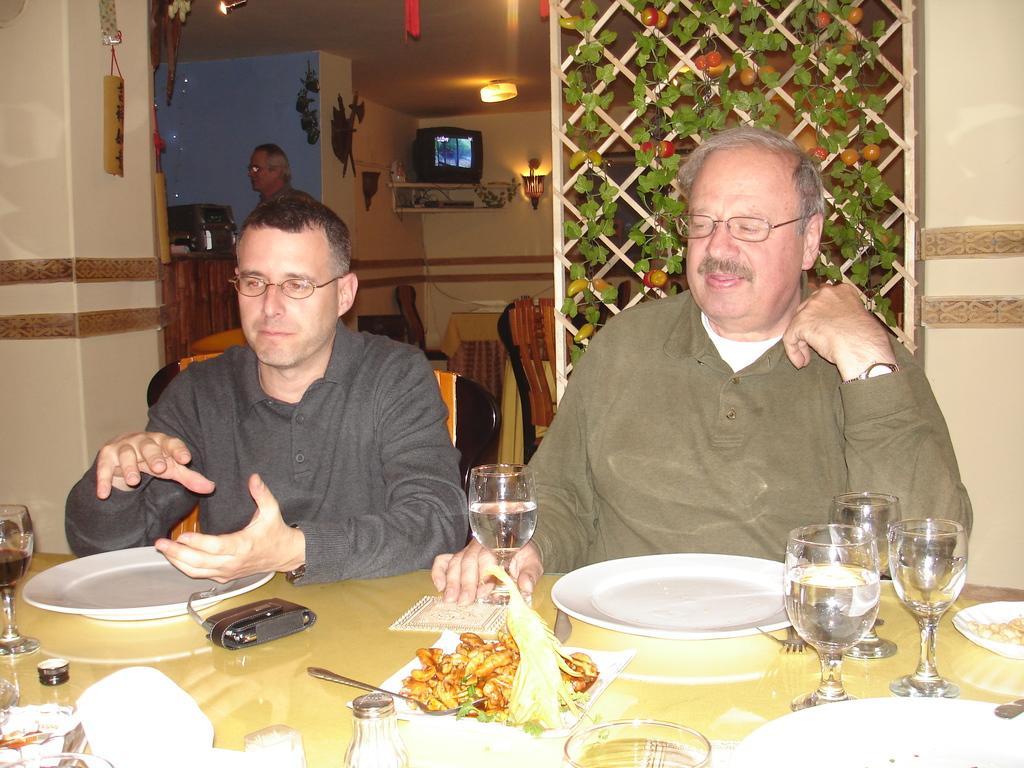Describe this image in one or two sentences. In this image we can see few people sitting on the chairs. There is a television on the wooden object in the image. There are few house plants in the image. We can see few plates, few glasses and few other objects placed on the table. A person is standing at the left side of the image. There are few lamps in the image. 